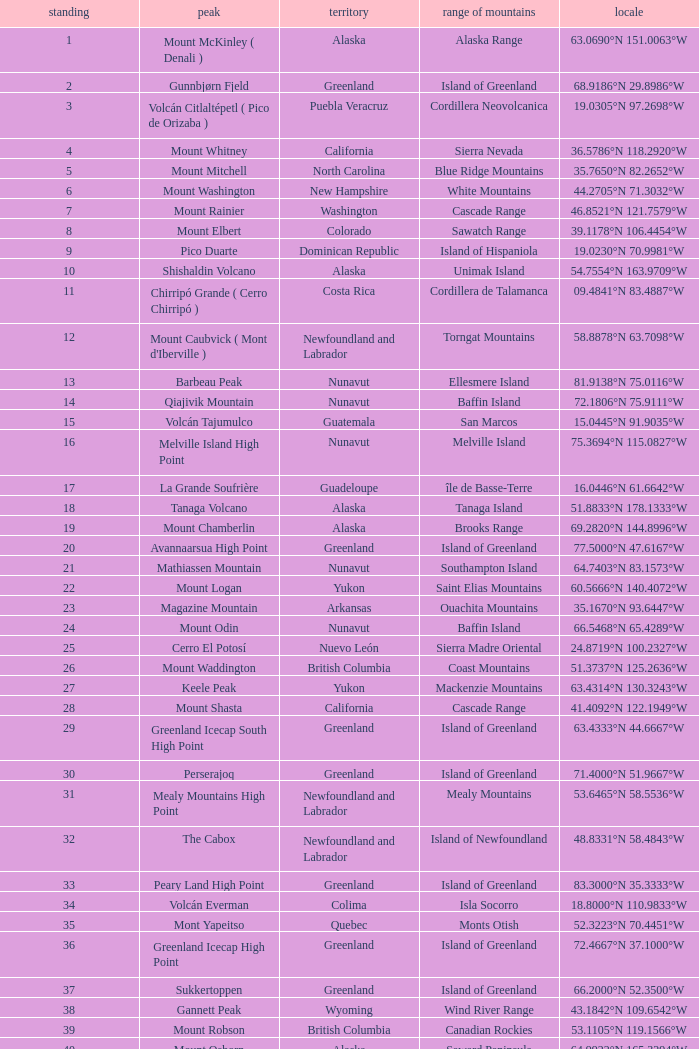Which Mountain Peak has a Region of baja california, and a Location of 28.1301°n 115.2206°w? Isla Cedros High Point. 